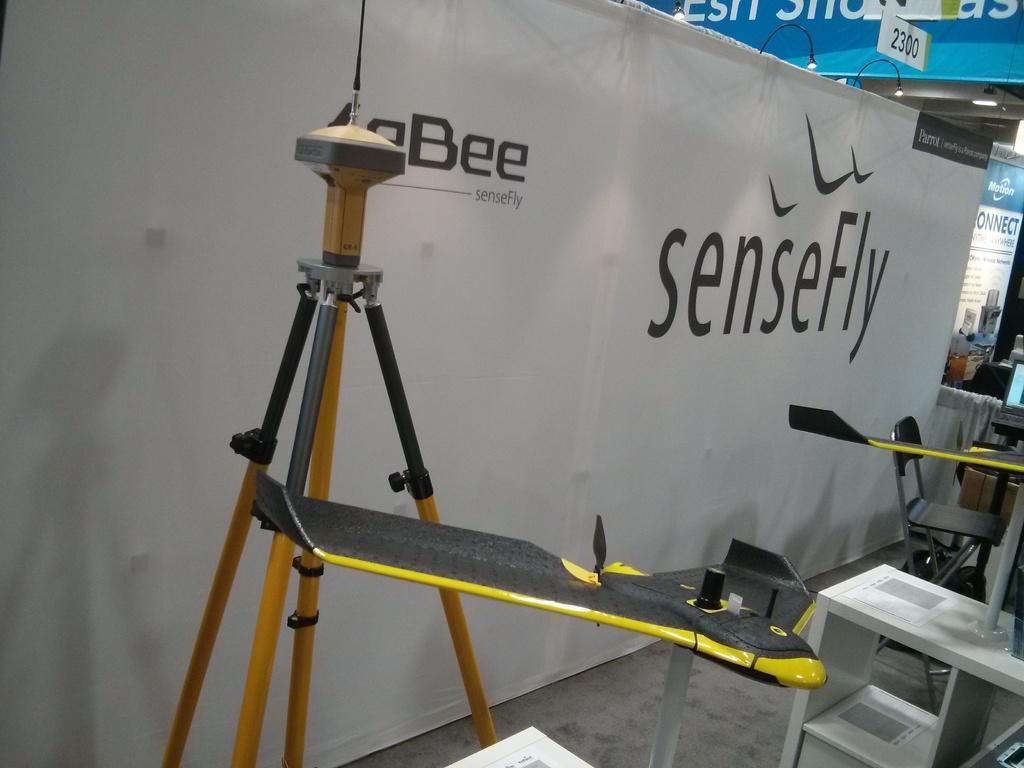Could you give a brief overview of what you see in this image? In front of the image there is a stand with black and yellow color object. On the right side of the image there is a table with racks and papers. And also there are chairs and few other things. Behind the chair there is a banner with text on it. In the background there is a poster and board with text on it. 